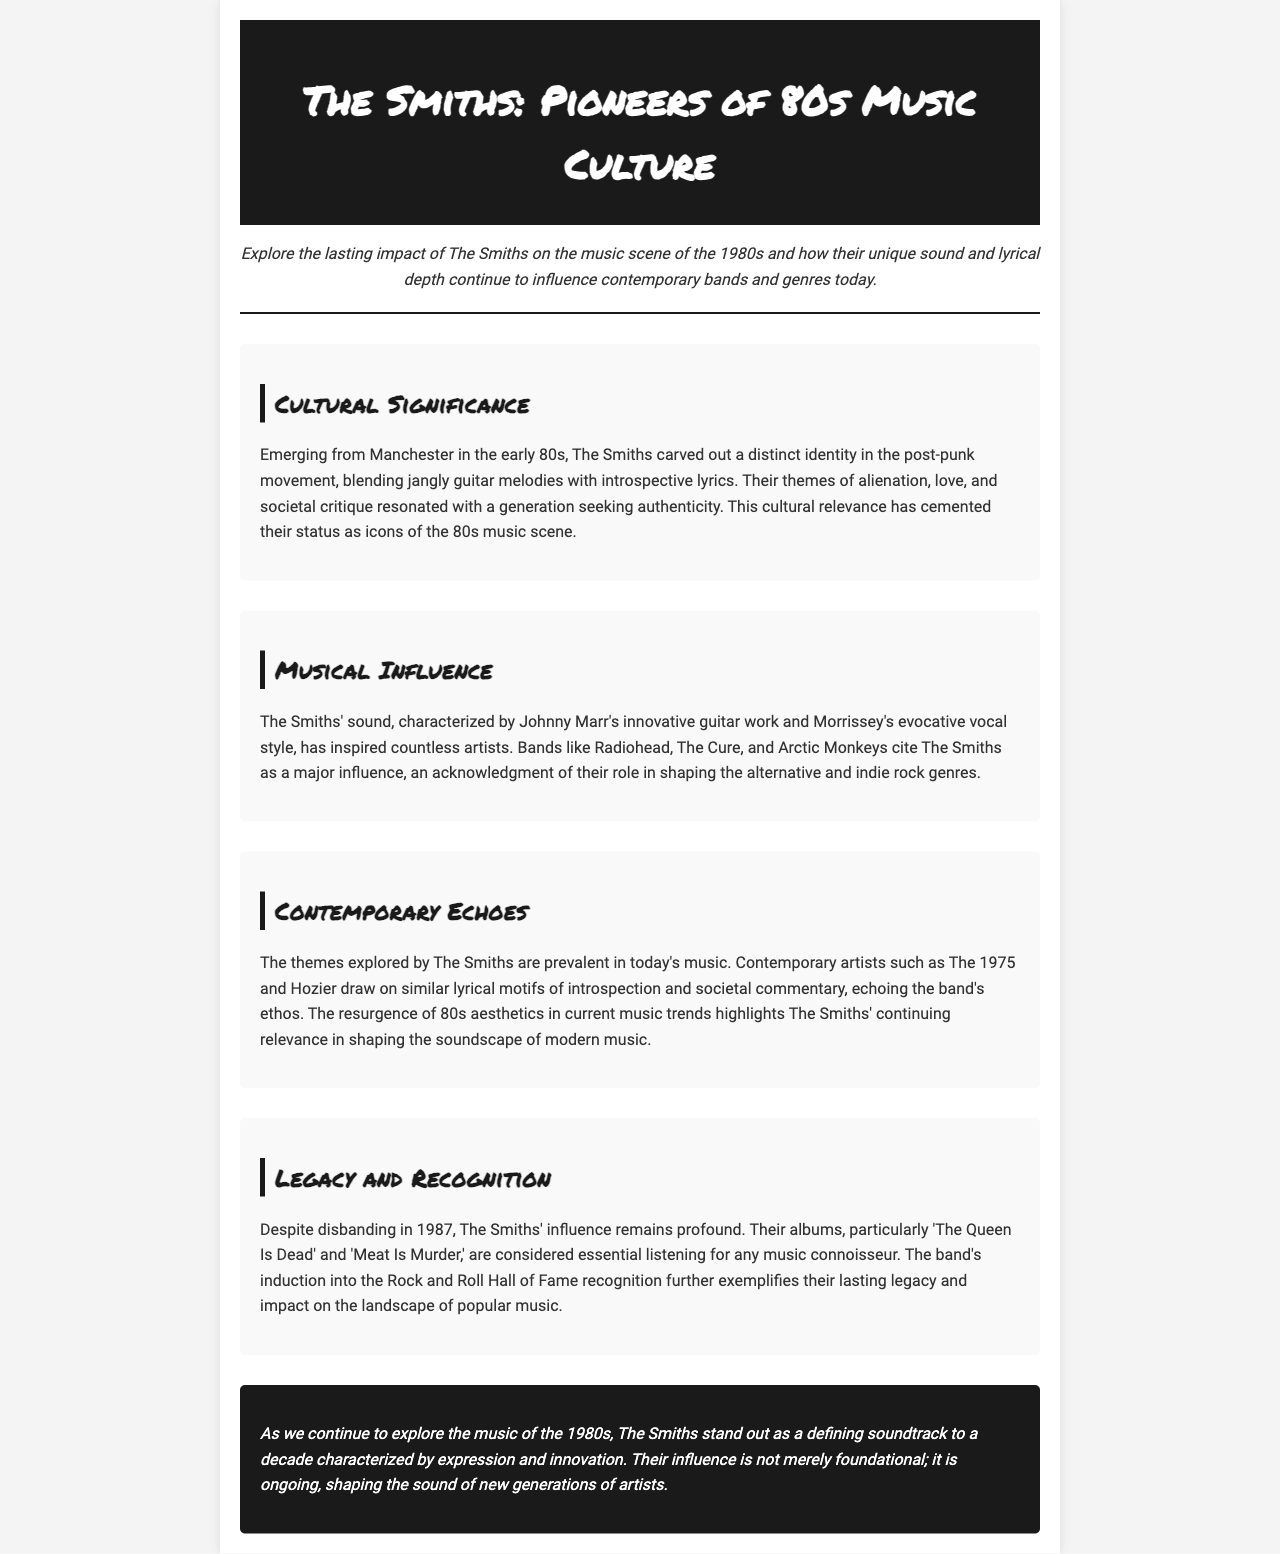What band is the focus of the newsletter? The title and content of the newsletter clearly indicate the focus is on The Smiths.
Answer: The Smiths In what city did The Smiths emerge? The document mentions that The Smiths emerged from Manchester in the early 80s.
Answer: Manchester What is a significant album mentioned in the document? The section on Legacy and Recognition specifies 'The Queen Is Dead' as an essential album.
Answer: The Queen Is Dead Which contemporary band cites The Smiths as an influence? The newsletter lists several bands, including Radiohead, that acknowledge The Smiths' influence.
Answer: Radiohead What themes are prevalent in today's music according to the document? The newsletter indicates that themes of introspection and societal commentary are prevalent in contemporary music, similar to The Smiths.
Answer: Introspection and societal commentary How did The Smiths influence alternative music? The document states that The Smiths' sound has inspired countless artists, shaping alternative and indie rock genres.
Answer: Shaping alternative and indie rock Why are The Smiths regarded as icons of the 80s music scene? The newsletter mentions that their themes of alienation, love, and societal critique resonated with a generation seeking authenticity.
Answer: Themes of alienation, love, and societal critique What style of music is The Smiths associated with? The introduction and musical influence sections refer to their unique sound in the post-punk movement.
Answer: Post-punk What year did The Smiths disband? The document states that The Smiths disbanded in 1987.
Answer: 1987 